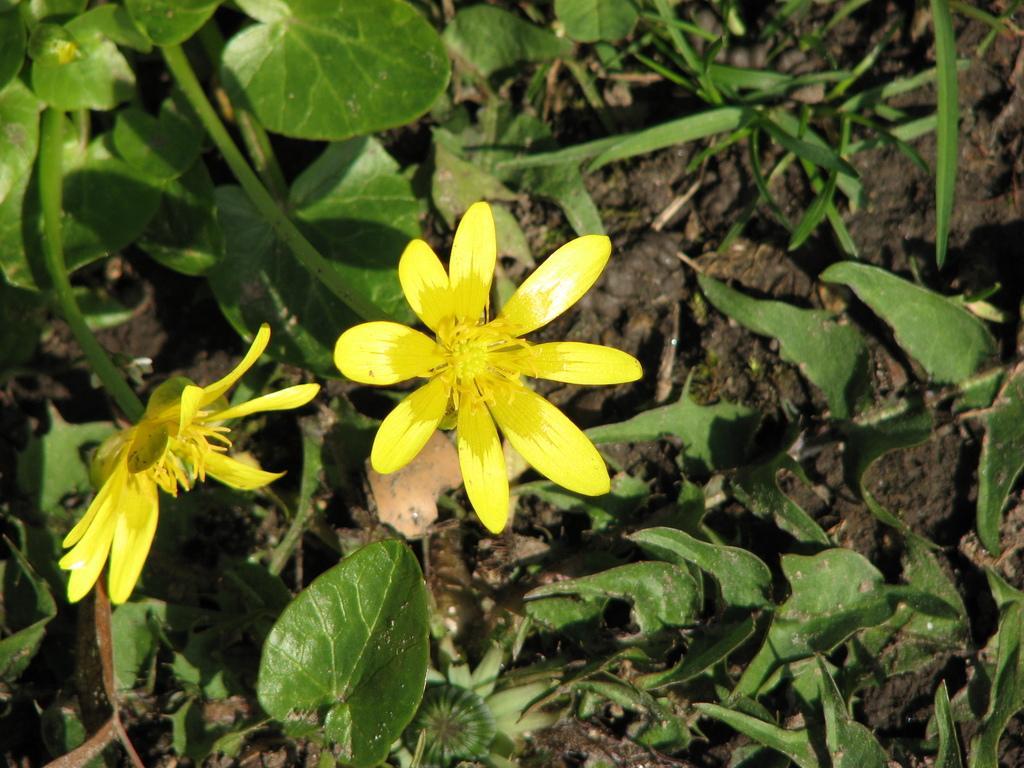Describe this image in one or two sentences. In this picture we can see the soil, leaves, stems and flowers. 